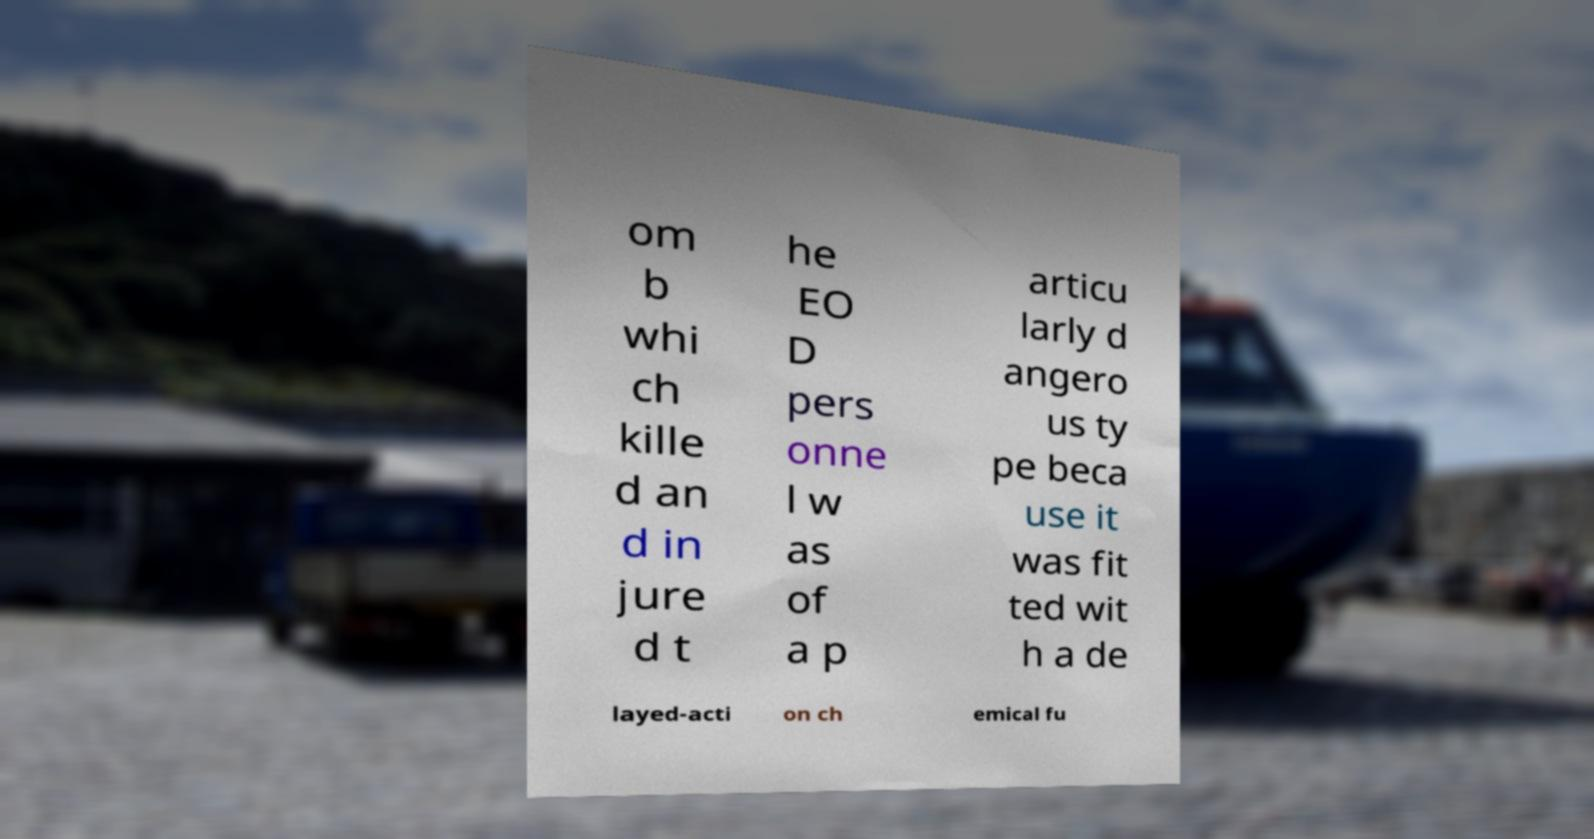For documentation purposes, I need the text within this image transcribed. Could you provide that? om b whi ch kille d an d in jure d t he EO D pers onne l w as of a p articu larly d angero us ty pe beca use it was fit ted wit h a de layed-acti on ch emical fu 